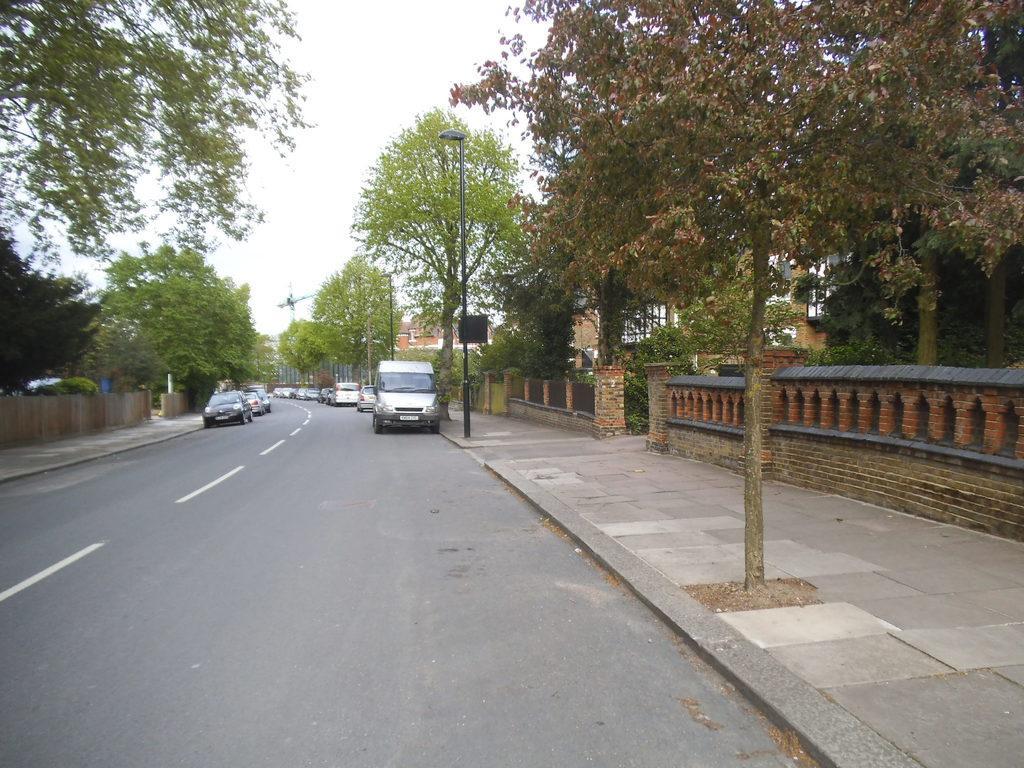Could you give a brief overview of what you see in this image? In this image I can see the road, few vehicles on the road, the sidewalk, few poles and few trees which are green and brown in color. I can see few buildings and in the background I can see the sky. 